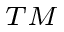<formula> <loc_0><loc_0><loc_500><loc_500>^ { T M }</formula> 